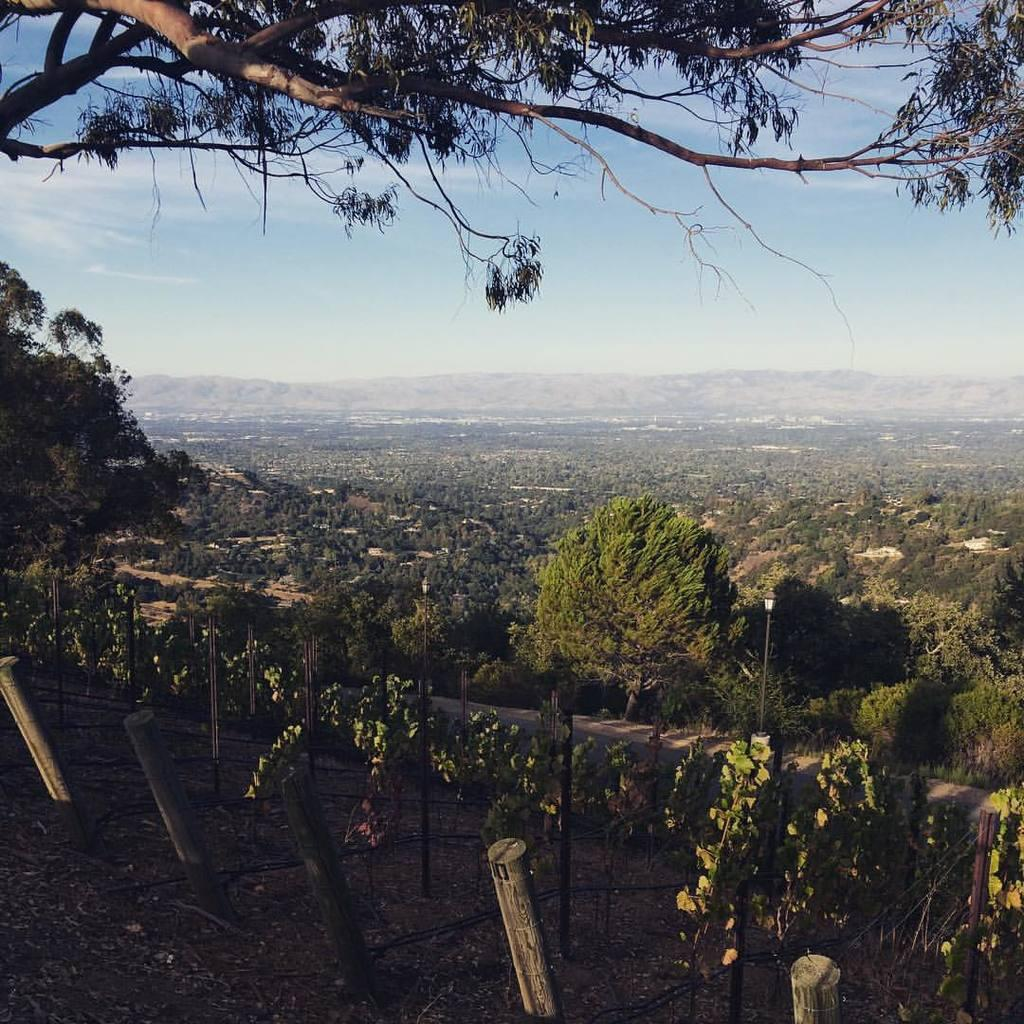What type of vegetation can be seen in the image? There are plants and trees visible in the image. What structures are present in the image? There are poles in the image. What type of illumination is present in the image? There are lights in the image. What can be seen in the background of the image? There are hills and clouds visible in the background of the image. What type of screw is being used to make a decision in the image? There is no screw or decision-making process depicted in the image. What time of day is it in the image? The time of day is not specified in the image, so we cannot determine if it is morning or any other time. 